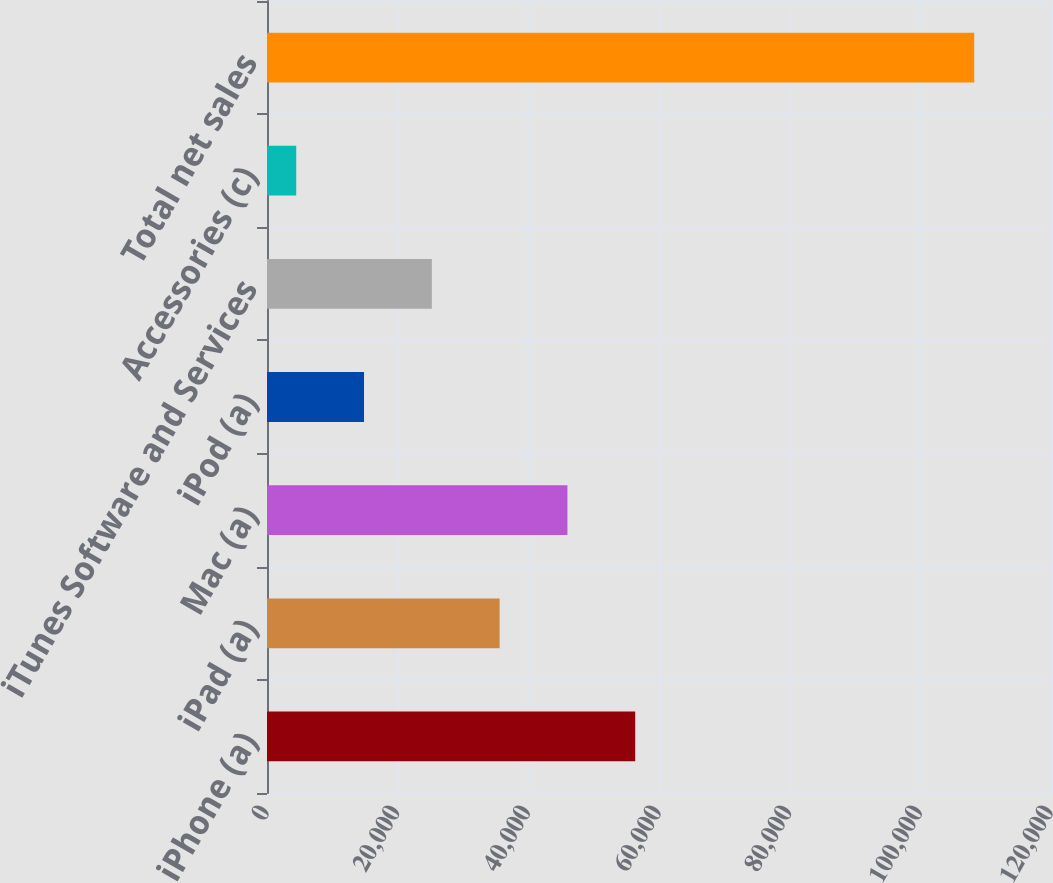Convert chart. <chart><loc_0><loc_0><loc_500><loc_500><bar_chart><fcel>iPhone (a)<fcel>iPad (a)<fcel>Mac (a)<fcel>iPod (a)<fcel>iTunes Software and Services<fcel>Accessories (c)<fcel>Total net sales<nl><fcel>56361.5<fcel>35606.5<fcel>45984<fcel>14851.5<fcel>25229<fcel>4474<fcel>108249<nl></chart> 